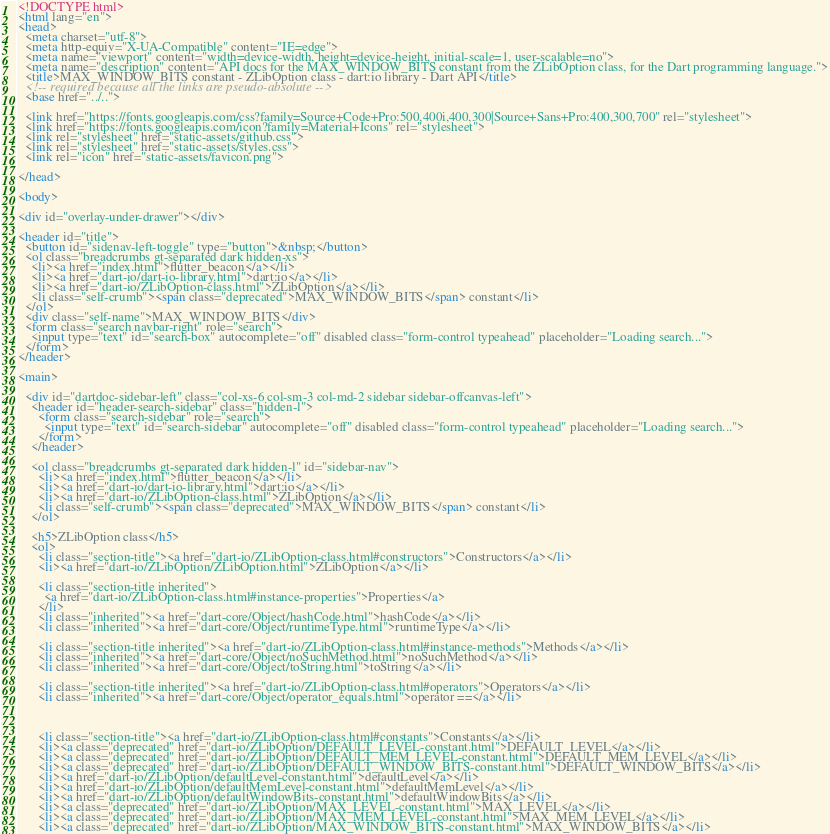Convert code to text. <code><loc_0><loc_0><loc_500><loc_500><_HTML_><!DOCTYPE html>
<html lang="en">
<head>
  <meta charset="utf-8">
  <meta http-equiv="X-UA-Compatible" content="IE=edge">
  <meta name="viewport" content="width=device-width, height=device-height, initial-scale=1, user-scalable=no">
  <meta name="description" content="API docs for the MAX_WINDOW_BITS constant from the ZLibOption class, for the Dart programming language.">
  <title>MAX_WINDOW_BITS constant - ZLibOption class - dart:io library - Dart API</title>
  <!-- required because all the links are pseudo-absolute -->
  <base href="../..">

  <link href="https://fonts.googleapis.com/css?family=Source+Code+Pro:500,400i,400,300|Source+Sans+Pro:400,300,700" rel="stylesheet">
  <link href="https://fonts.googleapis.com/icon?family=Material+Icons" rel="stylesheet">
  <link rel="stylesheet" href="static-assets/github.css">
  <link rel="stylesheet" href="static-assets/styles.css">
  <link rel="icon" href="static-assets/favicon.png">
  
</head>

<body>

<div id="overlay-under-drawer"></div>

<header id="title">
  <button id="sidenav-left-toggle" type="button">&nbsp;</button>
  <ol class="breadcrumbs gt-separated dark hidden-xs">
    <li><a href="index.html">flutter_beacon</a></li>
    <li><a href="dart-io/dart-io-library.html">dart:io</a></li>
    <li><a href="dart-io/ZLibOption-class.html">ZLibOption</a></li>
    <li class="self-crumb"><span class="deprecated">MAX_WINDOW_BITS</span> constant</li>
  </ol>
  <div class="self-name">MAX_WINDOW_BITS</div>
  <form class="search navbar-right" role="search">
    <input type="text" id="search-box" autocomplete="off" disabled class="form-control typeahead" placeholder="Loading search...">
  </form>
</header>

<main>

  <div id="dartdoc-sidebar-left" class="col-xs-6 col-sm-3 col-md-2 sidebar sidebar-offcanvas-left">
    <header id="header-search-sidebar" class="hidden-l">
      <form class="search-sidebar" role="search">
        <input type="text" id="search-sidebar" autocomplete="off" disabled class="form-control typeahead" placeholder="Loading search...">
      </form>
    </header>
    
    <ol class="breadcrumbs gt-separated dark hidden-l" id="sidebar-nav">
      <li><a href="index.html">flutter_beacon</a></li>
      <li><a href="dart-io/dart-io-library.html">dart:io</a></li>
      <li><a href="dart-io/ZLibOption-class.html">ZLibOption</a></li>
      <li class="self-crumb"><span class="deprecated">MAX_WINDOW_BITS</span> constant</li>
    </ol>
    
    <h5>ZLibOption class</h5>
    <ol>
      <li class="section-title"><a href="dart-io/ZLibOption-class.html#constructors">Constructors</a></li>
      <li><a href="dart-io/ZLibOption/ZLibOption.html">ZLibOption</a></li>
    
      <li class="section-title inherited">
        <a href="dart-io/ZLibOption-class.html#instance-properties">Properties</a>
      </li>
      <li class="inherited"><a href="dart-core/Object/hashCode.html">hashCode</a></li>
      <li class="inherited"><a href="dart-core/Object/runtimeType.html">runtimeType</a></li>
    
      <li class="section-title inherited"><a href="dart-io/ZLibOption-class.html#instance-methods">Methods</a></li>
      <li class="inherited"><a href="dart-core/Object/noSuchMethod.html">noSuchMethod</a></li>
      <li class="inherited"><a href="dart-core/Object/toString.html">toString</a></li>
    
      <li class="section-title inherited"><a href="dart-io/ZLibOption-class.html#operators">Operators</a></li>
      <li class="inherited"><a href="dart-core/Object/operator_equals.html">operator ==</a></li>
    
    
    
      <li class="section-title"><a href="dart-io/ZLibOption-class.html#constants">Constants</a></li>
      <li><a class="deprecated" href="dart-io/ZLibOption/DEFAULT_LEVEL-constant.html">DEFAULT_LEVEL</a></li>
      <li><a class="deprecated" href="dart-io/ZLibOption/DEFAULT_MEM_LEVEL-constant.html">DEFAULT_MEM_LEVEL</a></li>
      <li><a class="deprecated" href="dart-io/ZLibOption/DEFAULT_WINDOW_BITS-constant.html">DEFAULT_WINDOW_BITS</a></li>
      <li><a href="dart-io/ZLibOption/defaultLevel-constant.html">defaultLevel</a></li>
      <li><a href="dart-io/ZLibOption/defaultMemLevel-constant.html">defaultMemLevel</a></li>
      <li><a href="dart-io/ZLibOption/defaultWindowBits-constant.html">defaultWindowBits</a></li>
      <li><a class="deprecated" href="dart-io/ZLibOption/MAX_LEVEL-constant.html">MAX_LEVEL</a></li>
      <li><a class="deprecated" href="dart-io/ZLibOption/MAX_MEM_LEVEL-constant.html">MAX_MEM_LEVEL</a></li>
      <li><a class="deprecated" href="dart-io/ZLibOption/MAX_WINDOW_BITS-constant.html">MAX_WINDOW_BITS</a></li></code> 